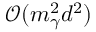<formula> <loc_0><loc_0><loc_500><loc_500>\mathcal { O } ( m _ { \gamma } ^ { 2 } d ^ { 2 } )</formula> 